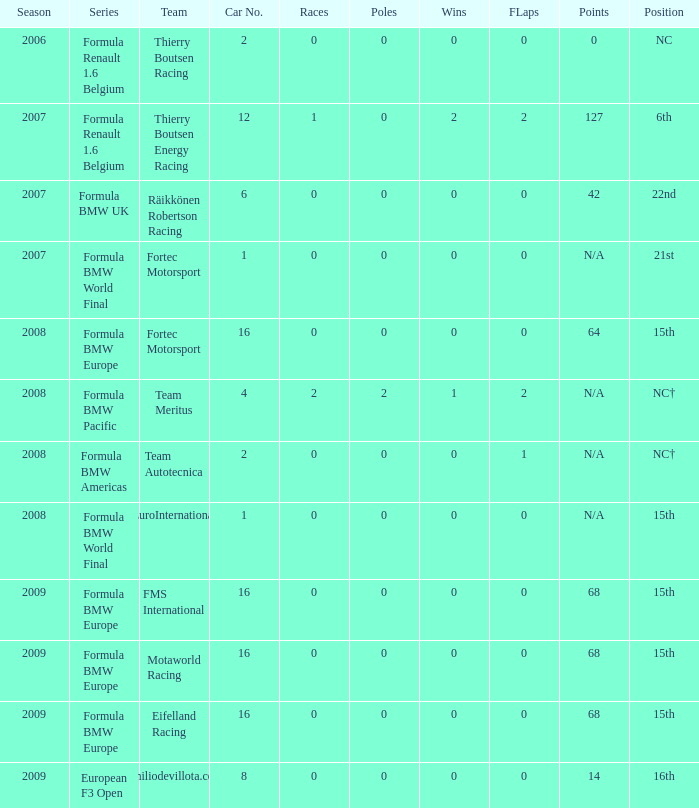Help me parse the entirety of this table. {'header': ['Season', 'Series', 'Team', 'Car No.', 'Races', 'Poles', 'Wins', 'FLaps', 'Points', 'Position'], 'rows': [['2006', 'Formula Renault 1.6 Belgium', 'Thierry Boutsen Racing', '2', '0', '0', '0', '0', '0', 'NC'], ['2007', 'Formula Renault 1.6 Belgium', 'Thierry Boutsen Energy Racing', '12', '1', '0', '2', '2', '127', '6th'], ['2007', 'Formula BMW UK', 'Räikkönen Robertson Racing', '6', '0', '0', '0', '0', '42', '22nd'], ['2007', 'Formula BMW World Final', 'Fortec Motorsport', '1', '0', '0', '0', '0', 'N/A', '21st'], ['2008', 'Formula BMW Europe', 'Fortec Motorsport', '16', '0', '0', '0', '0', '64', '15th'], ['2008', 'Formula BMW Pacific', 'Team Meritus', '4', '2', '2', '1', '2', 'N/A', 'NC†'], ['2008', 'Formula BMW Americas', 'Team Autotecnica', '2', '0', '0', '0', '1', 'N/A', 'NC†'], ['2008', 'Formula BMW World Final', 'EuroInternational', '1', '0', '0', '0', '0', 'N/A', '15th'], ['2009', 'Formula BMW Europe', 'FMS International', '16', '0', '0', '0', '0', '68', '15th'], ['2009', 'Formula BMW Europe', 'Motaworld Racing', '16', '0', '0', '0', '0', '68', '15th'], ['2009', 'Formula BMW Europe', 'Eifelland Racing', '16', '0', '0', '0', '0', '68', '15th'], ['2009', 'European F3 Open', 'Emiliodevillota.com', '8', '0', '0', '0', '0', '14', '16th']]} Identify the role for eifelland racing. 15th. 